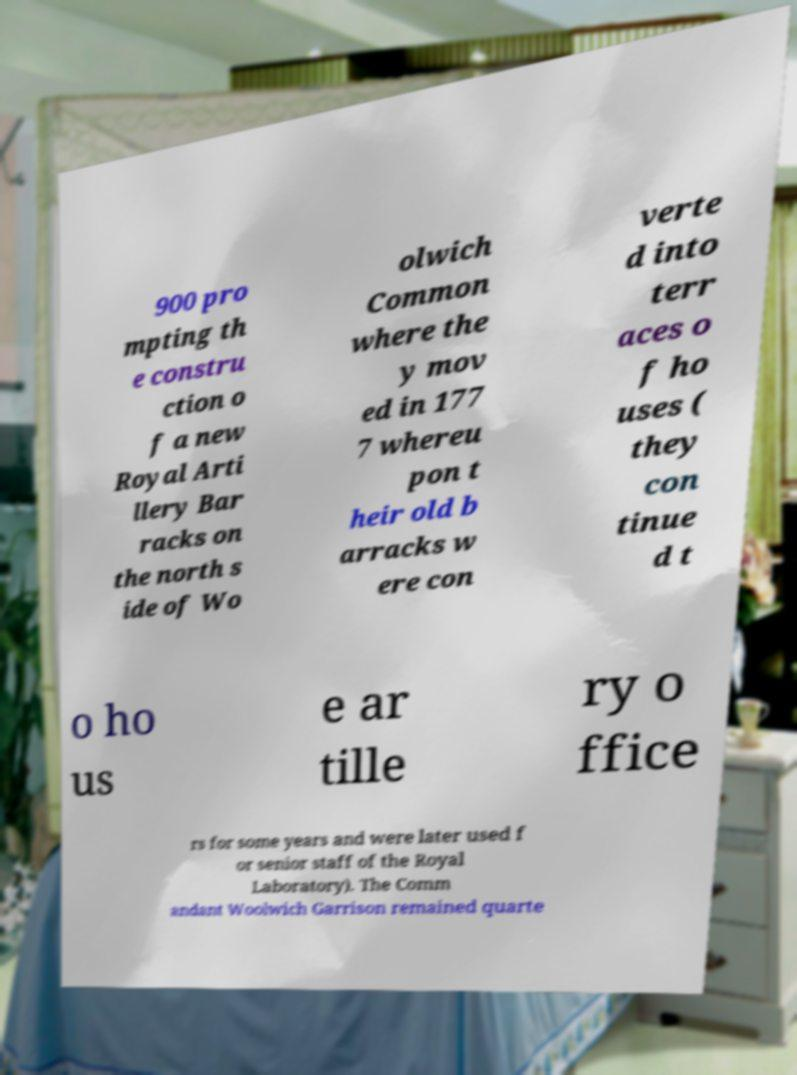For documentation purposes, I need the text within this image transcribed. Could you provide that? 900 pro mpting th e constru ction o f a new Royal Arti llery Bar racks on the north s ide of Wo olwich Common where the y mov ed in 177 7 whereu pon t heir old b arracks w ere con verte d into terr aces o f ho uses ( they con tinue d t o ho us e ar tille ry o ffice rs for some years and were later used f or senior staff of the Royal Laboratory). The Comm andant Woolwich Garrison remained quarte 